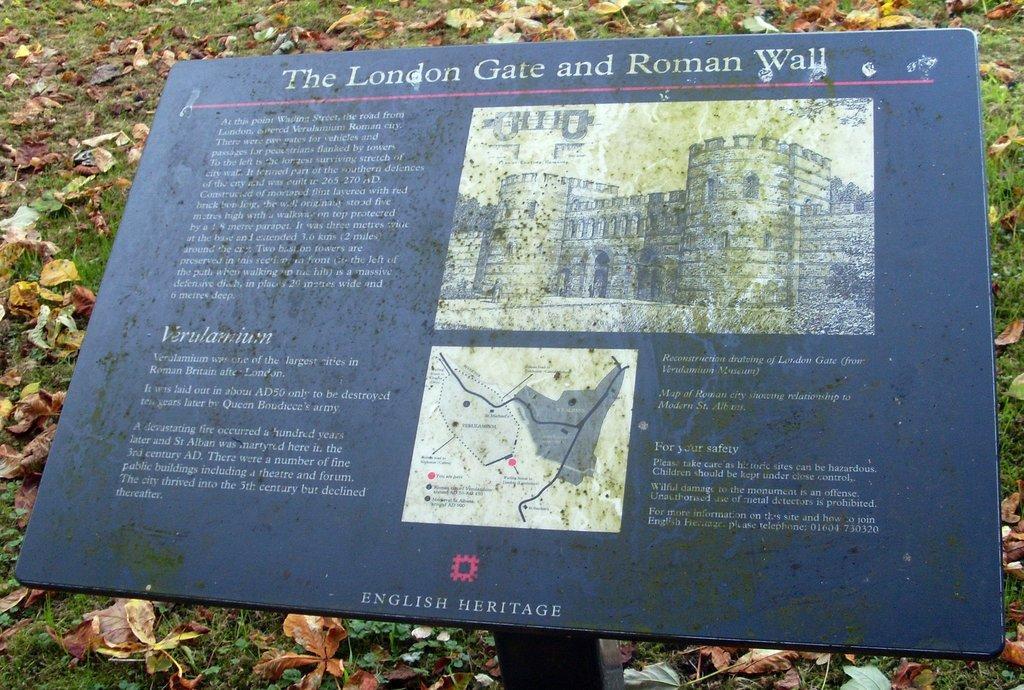How would you summarize this image in a sentence or two? We can see board on pole, grass and leaves. 